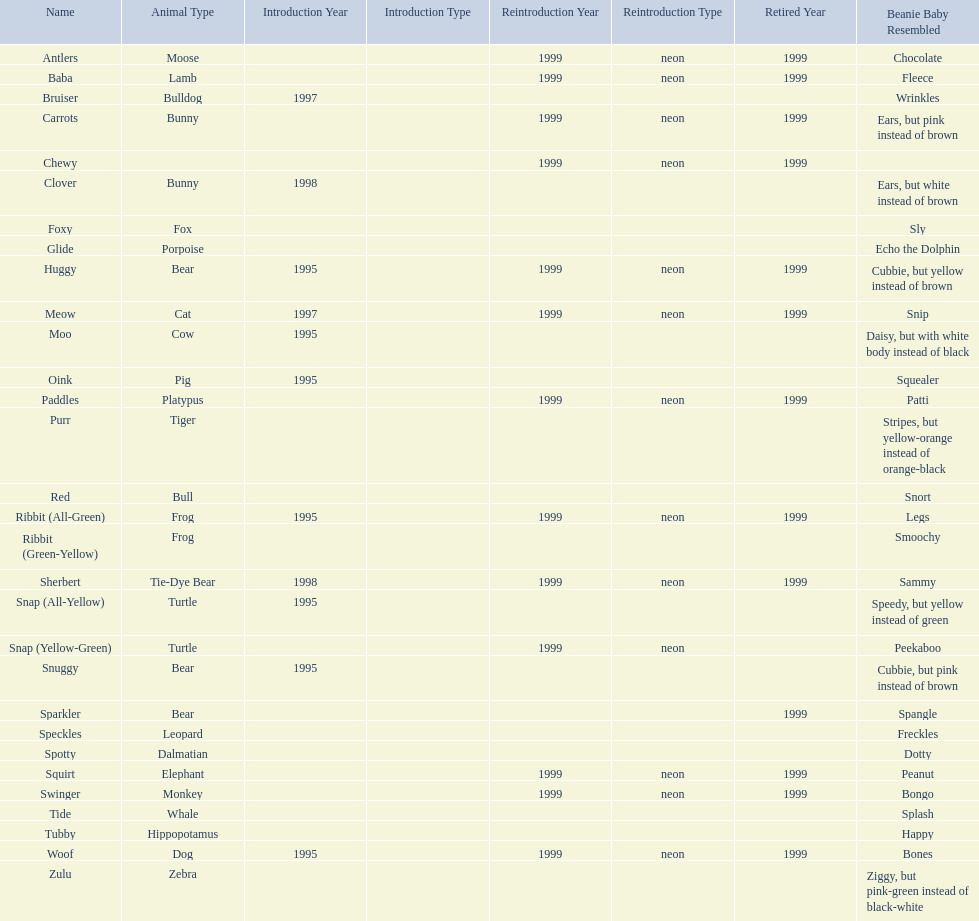What are the types of pillow pal animals? Antlers, Moose, Lamb, Bulldog, Bunny, , Bunny, Fox, Porpoise, Bear, Cat, Cow, Pig, Platypus, Tiger, Bull, Frog, Frog, Tie-Dye Bear, Turtle, Turtle, Bear, Bear, Leopard, Dalmatian, Elephant, Monkey, Whale, Hippopotamus, Dog, Zebra. Of those, which is a dalmatian? Dalmatian. What is the name of the dalmatian? Spotty. 